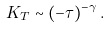Convert formula to latex. <formula><loc_0><loc_0><loc_500><loc_500>K _ { T } \sim ( - \tau ) ^ { - \gamma } \, .</formula> 